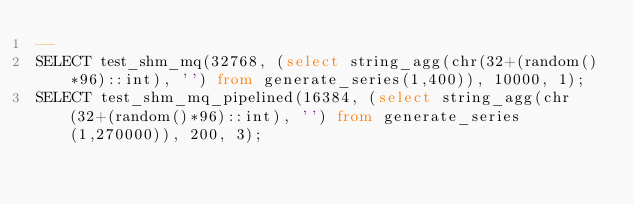Convert code to text. <code><loc_0><loc_0><loc_500><loc_500><_SQL_>--
SELECT test_shm_mq(32768, (select string_agg(chr(32+(random()*96)::int), '') from generate_series(1,400)), 10000, 1);
SELECT test_shm_mq_pipelined(16384, (select string_agg(chr(32+(random()*96)::int), '') from generate_series(1,270000)), 200, 3);
</code> 